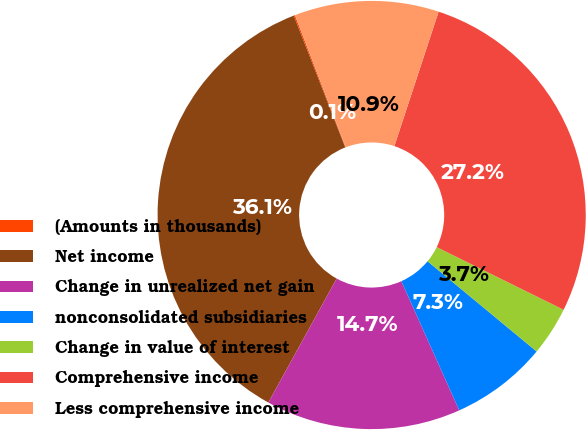Convert chart to OTSL. <chart><loc_0><loc_0><loc_500><loc_500><pie_chart><fcel>(Amounts in thousands)<fcel>Net income<fcel>Change in unrealized net gain<fcel>nonconsolidated subsidiaries<fcel>Change in value of interest<fcel>Comprehensive income<fcel>Less comprehensive income<nl><fcel>0.1%<fcel>36.05%<fcel>14.72%<fcel>7.29%<fcel>3.7%<fcel>27.23%<fcel>10.89%<nl></chart> 